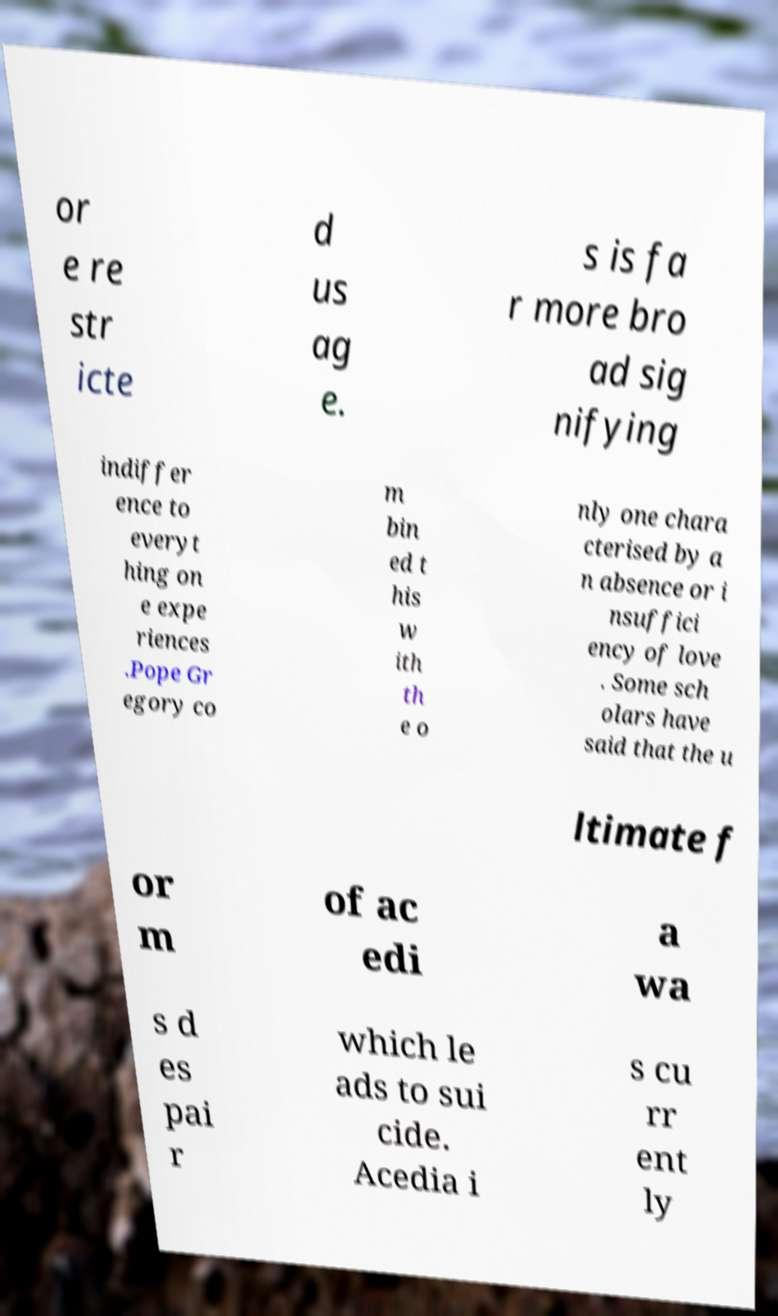Could you assist in decoding the text presented in this image and type it out clearly? or e re str icte d us ag e. s is fa r more bro ad sig nifying indiffer ence to everyt hing on e expe riences .Pope Gr egory co m bin ed t his w ith th e o nly one chara cterised by a n absence or i nsuffici ency of love . Some sch olars have said that the u ltimate f or m of ac edi a wa s d es pai r which le ads to sui cide. Acedia i s cu rr ent ly 